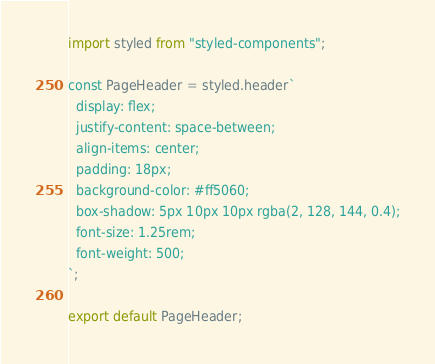Convert code to text. <code><loc_0><loc_0><loc_500><loc_500><_JavaScript_>import styled from "styled-components";

const PageHeader = styled.header`
  display: flex;
  justify-content: space-between;
  align-items: center;
  padding: 18px;
  background-color: #ff5060;
  box-shadow: 5px 10px 10px rgba(2, 128, 144, 0.4);
  font-size: 1.25rem;
  font-weight: 500;
`;

export default PageHeader;
</code> 